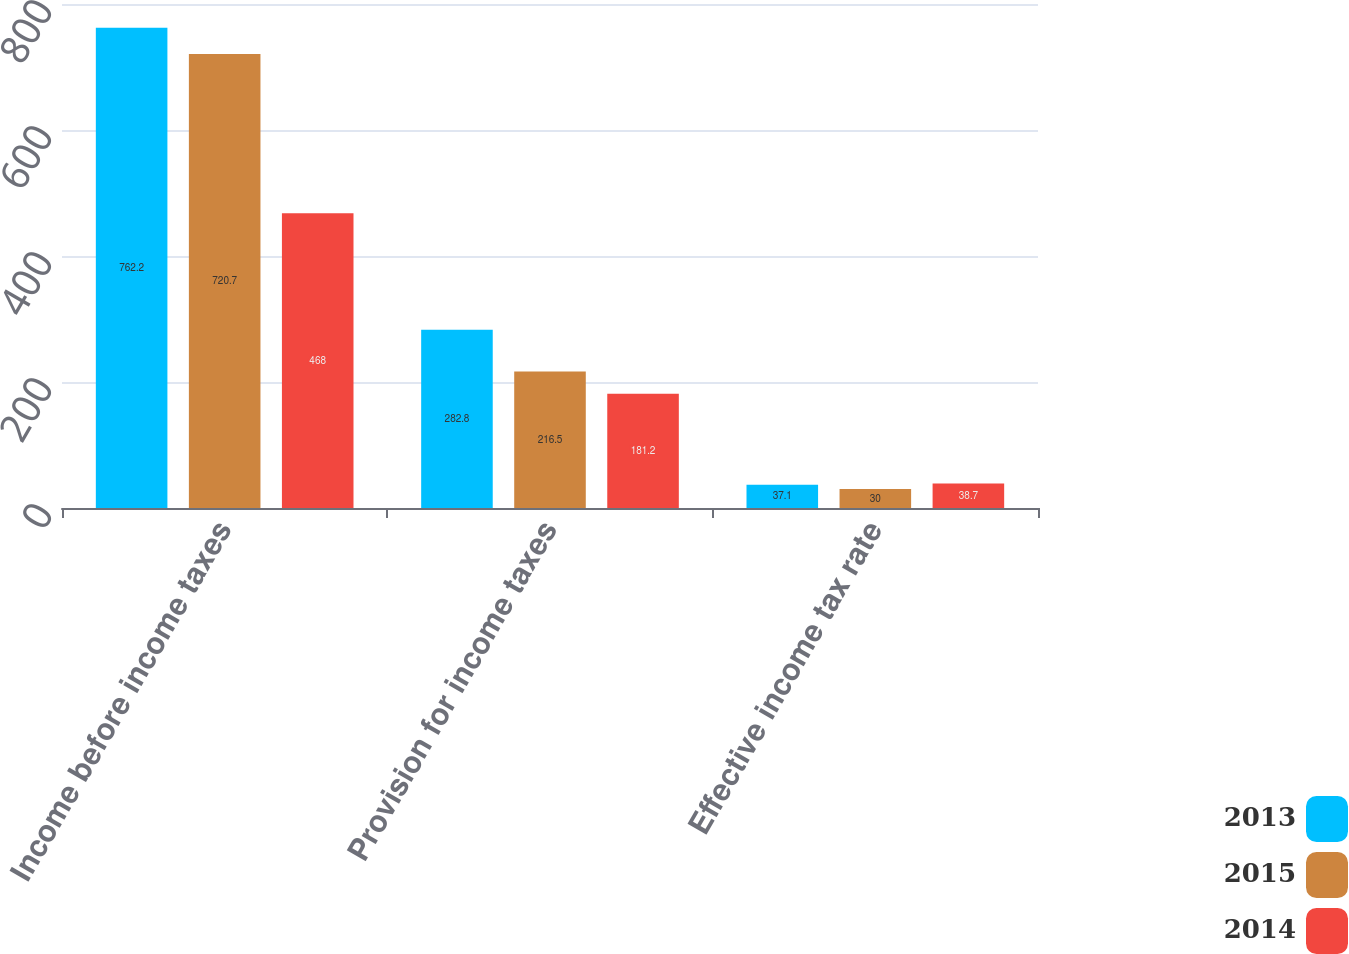Convert chart to OTSL. <chart><loc_0><loc_0><loc_500><loc_500><stacked_bar_chart><ecel><fcel>Income before income taxes<fcel>Provision for income taxes<fcel>Effective income tax rate<nl><fcel>2013<fcel>762.2<fcel>282.8<fcel>37.1<nl><fcel>2015<fcel>720.7<fcel>216.5<fcel>30<nl><fcel>2014<fcel>468<fcel>181.2<fcel>38.7<nl></chart> 